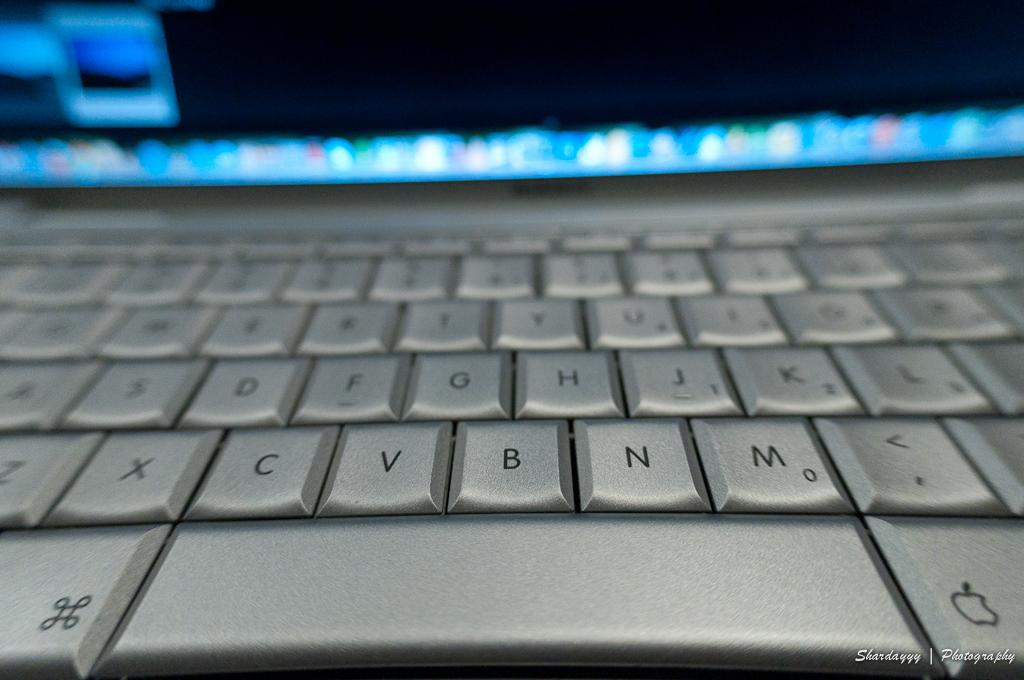<image>
Offer a succinct explanation of the picture presented. a metal keyboard closeup with keys like V, B and N 